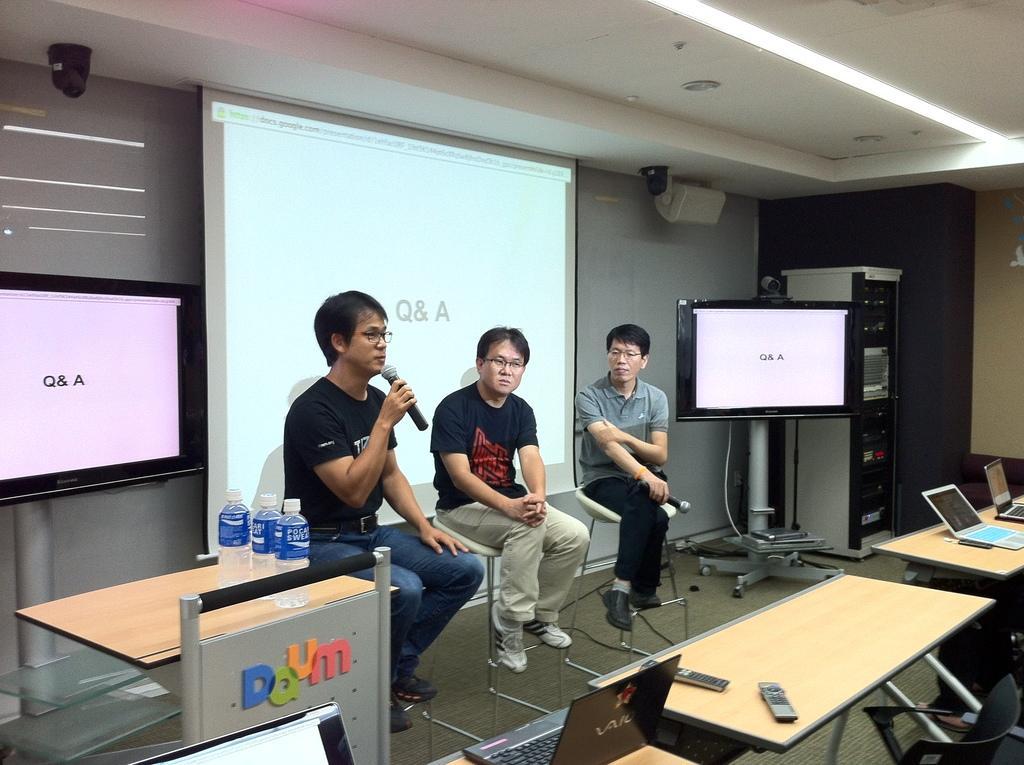Can you describe this image briefly? In the image in the center we can see three persons were sitting on the chair and holding microphones. On the left side of the image,there is a stand,board,table and water bottles. In the bottom of the image,we can see tables,chairs,laptops and remote. In the background there is a wall,roof,light,screen,stand,board,machine and few other objects. 